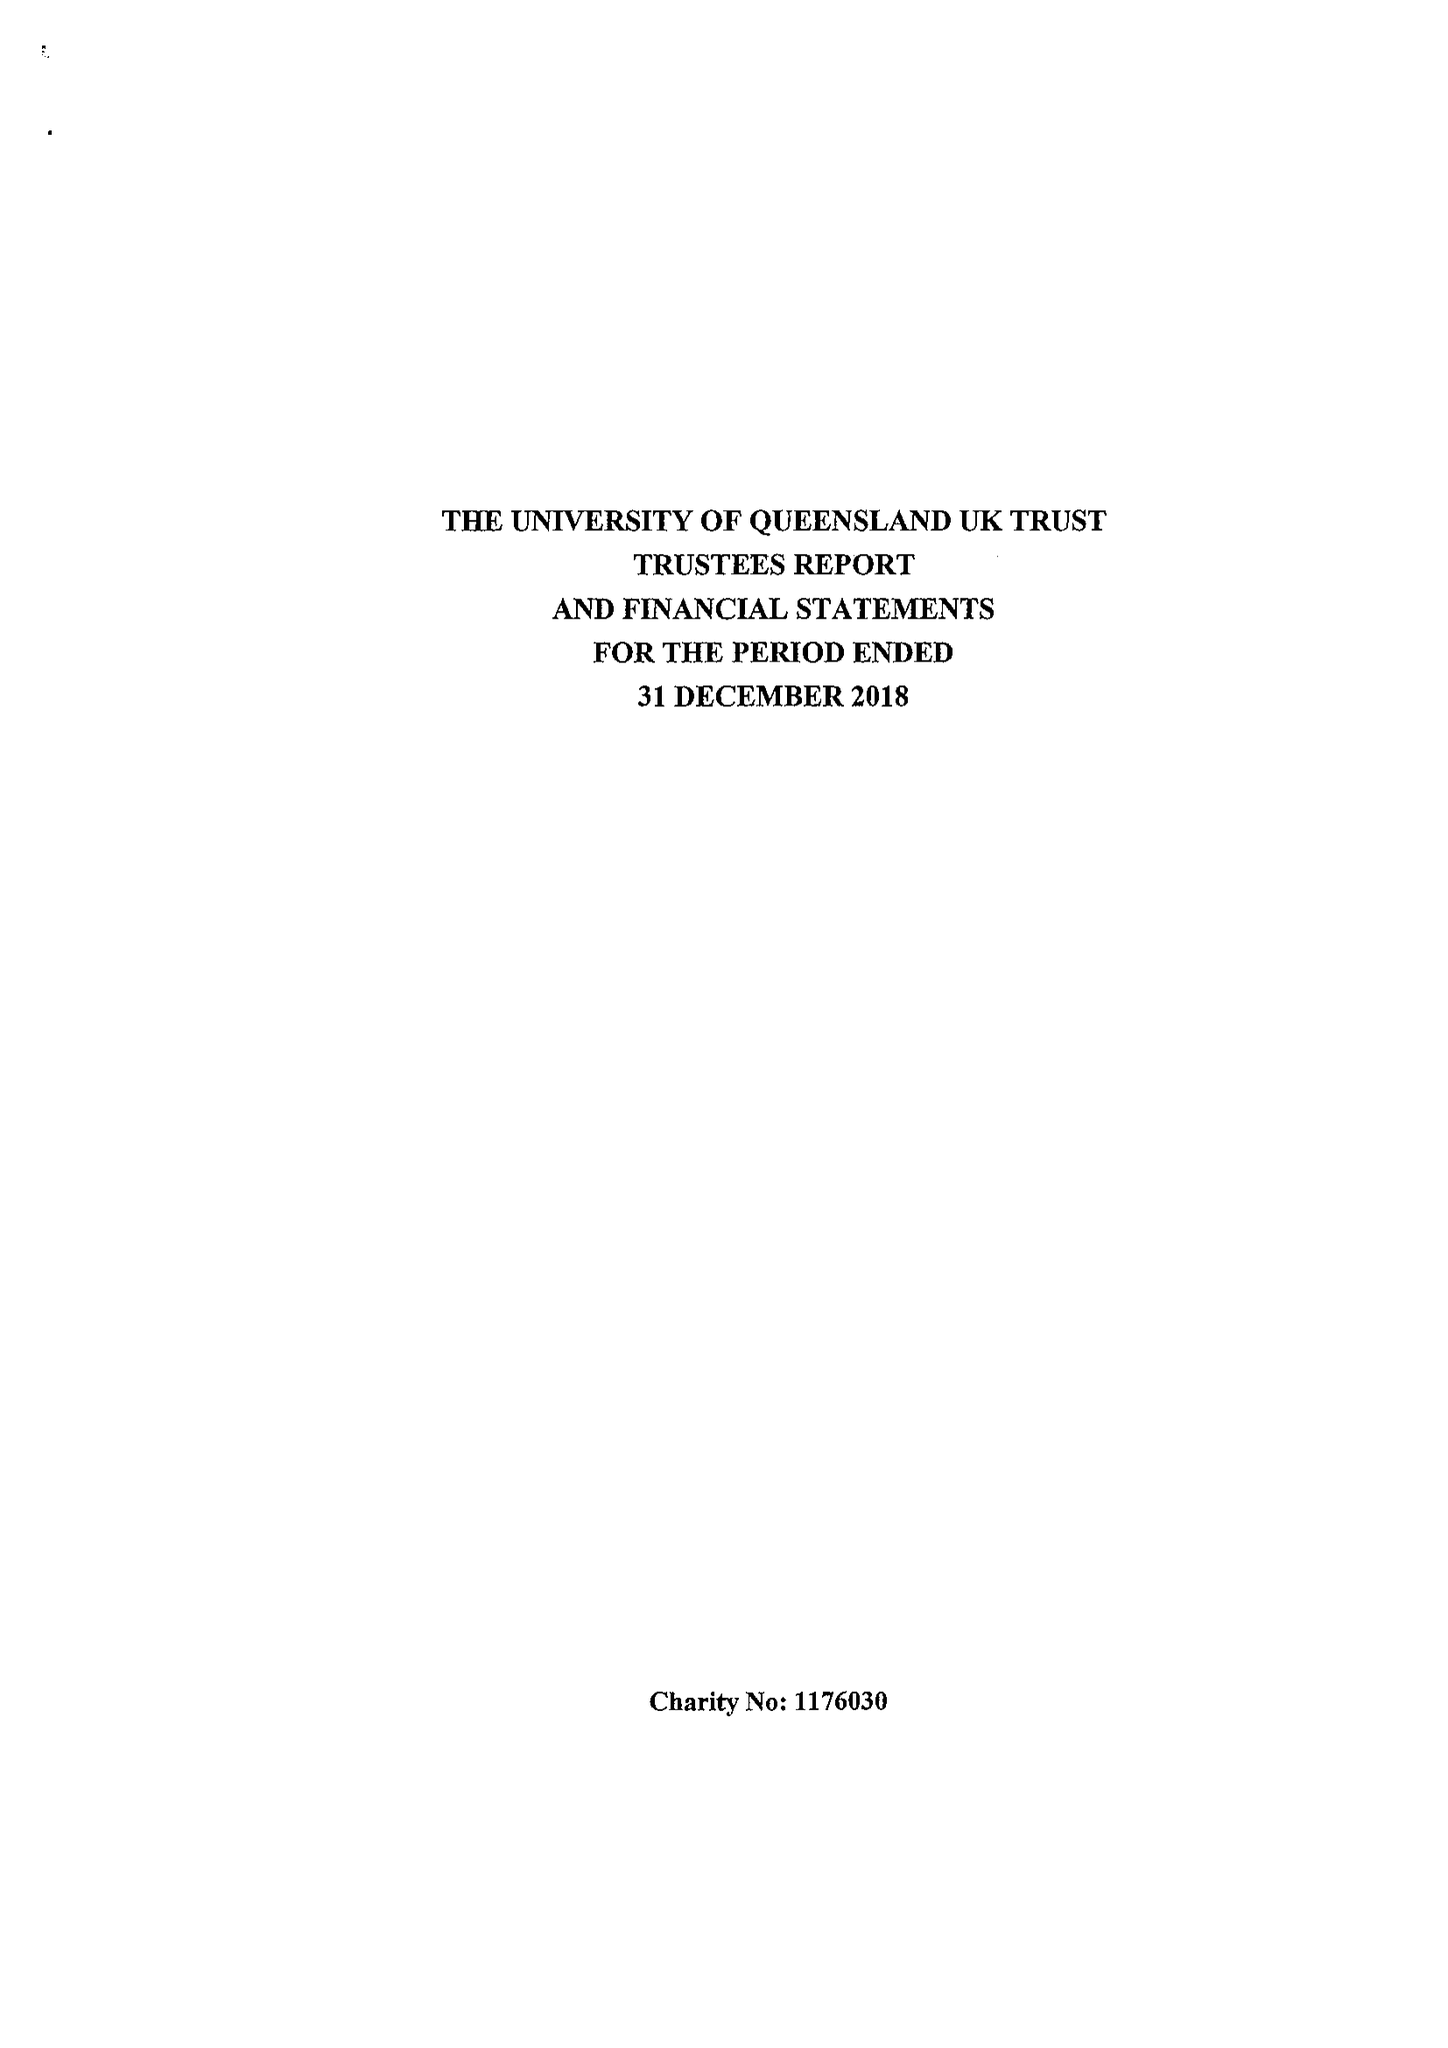What is the value for the address__postcode?
Answer the question using a single word or phrase. RH7 6PB 